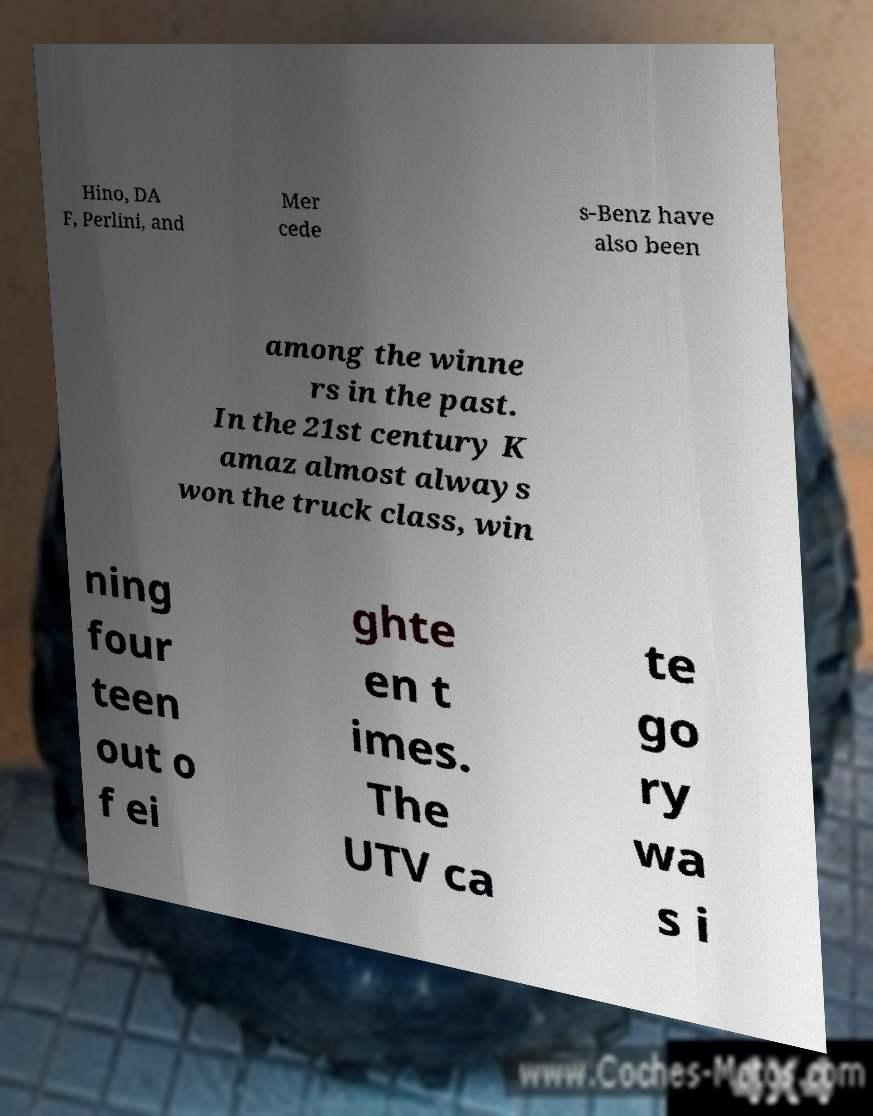Please identify and transcribe the text found in this image. Hino, DA F, Perlini, and Mer cede s-Benz have also been among the winne rs in the past. In the 21st century K amaz almost always won the truck class, win ning four teen out o f ei ghte en t imes. The UTV ca te go ry wa s i 